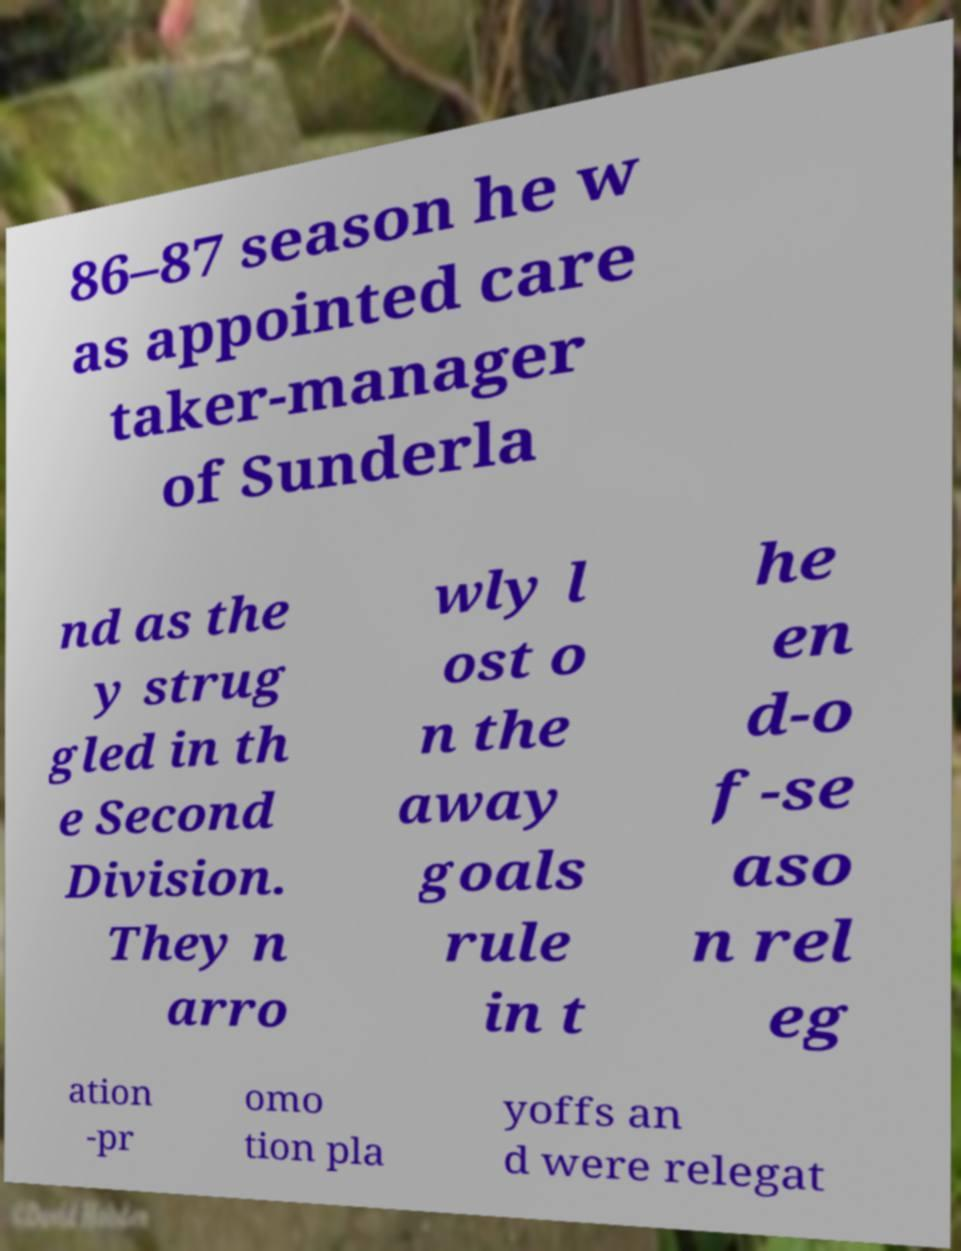What messages or text are displayed in this image? I need them in a readable, typed format. 86–87 season he w as appointed care taker-manager of Sunderla nd as the y strug gled in th e Second Division. They n arro wly l ost o n the away goals rule in t he en d-o f-se aso n rel eg ation -pr omo tion pla yoffs an d were relegat 